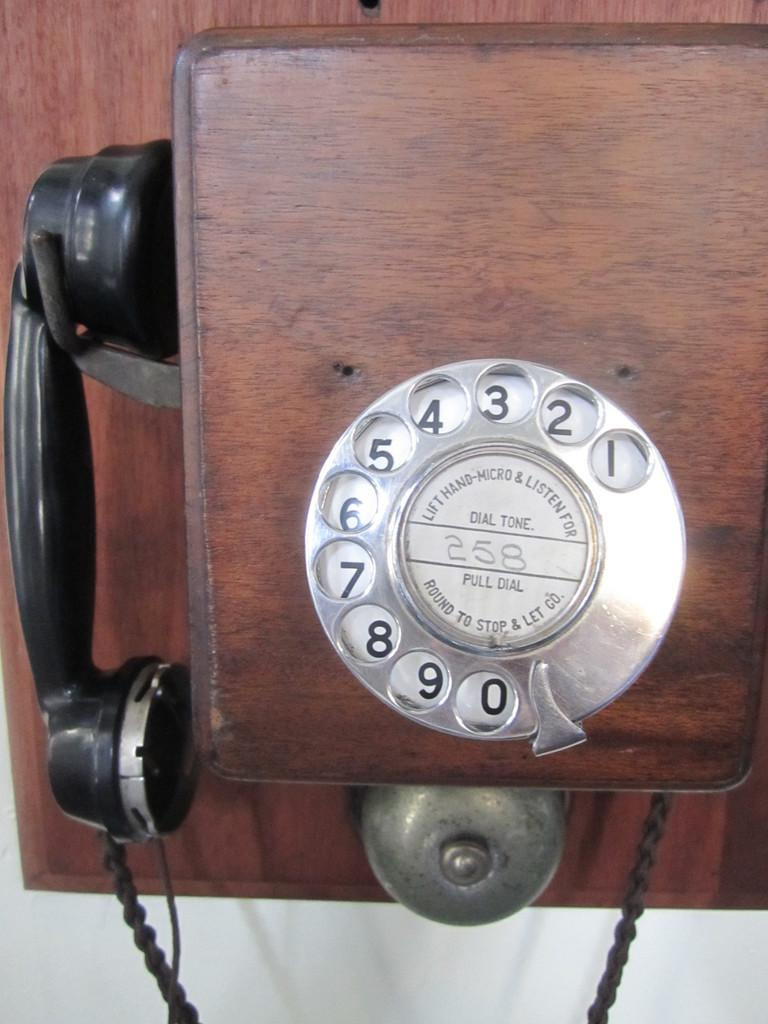<image>
Render a clear and concise summary of the photo. An old telephone has the number 258 hand-written in the center of the dial. 